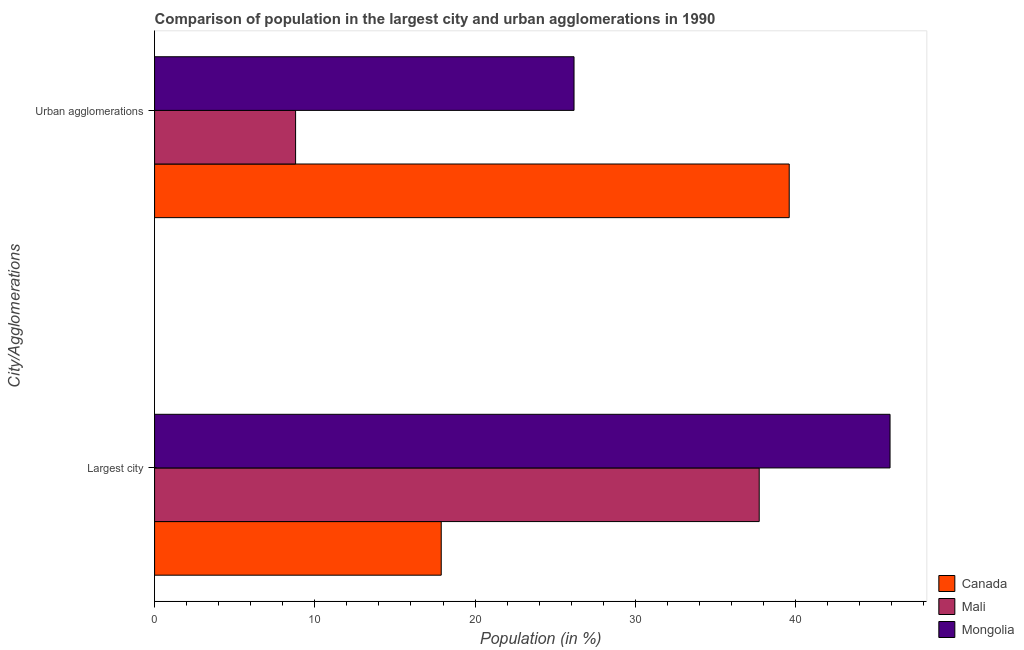How many groups of bars are there?
Keep it short and to the point. 2. Are the number of bars per tick equal to the number of legend labels?
Give a very brief answer. Yes. Are the number of bars on each tick of the Y-axis equal?
Provide a short and direct response. Yes. What is the label of the 1st group of bars from the top?
Your answer should be very brief. Urban agglomerations. What is the population in the largest city in Mongolia?
Give a very brief answer. 45.89. Across all countries, what is the maximum population in urban agglomerations?
Provide a short and direct response. 39.6. Across all countries, what is the minimum population in urban agglomerations?
Ensure brevity in your answer.  8.8. In which country was the population in the largest city maximum?
Offer a terse response. Mongolia. In which country was the population in the largest city minimum?
Ensure brevity in your answer.  Canada. What is the total population in urban agglomerations in the graph?
Provide a succinct answer. 74.58. What is the difference between the population in the largest city in Canada and that in Mongolia?
Provide a succinct answer. -28.01. What is the difference between the population in urban agglomerations in Mali and the population in the largest city in Mongolia?
Provide a short and direct response. -37.09. What is the average population in the largest city per country?
Provide a succinct answer. 33.84. What is the difference between the population in urban agglomerations and population in the largest city in Mongolia?
Provide a succinct answer. -19.72. In how many countries, is the population in urban agglomerations greater than 38 %?
Give a very brief answer. 1. What is the ratio of the population in urban agglomerations in Canada to that in Mongolia?
Provide a short and direct response. 1.51. What does the 2nd bar from the top in Largest city represents?
Your answer should be compact. Mali. What does the 3rd bar from the bottom in Largest city represents?
Your answer should be very brief. Mongolia. How many bars are there?
Give a very brief answer. 6. Are all the bars in the graph horizontal?
Give a very brief answer. Yes. Are the values on the major ticks of X-axis written in scientific E-notation?
Offer a terse response. No. Does the graph contain grids?
Give a very brief answer. No. What is the title of the graph?
Give a very brief answer. Comparison of population in the largest city and urban agglomerations in 1990. Does "Syrian Arab Republic" appear as one of the legend labels in the graph?
Provide a succinct answer. No. What is the label or title of the Y-axis?
Your answer should be compact. City/Agglomerations. What is the Population (in %) of Canada in Largest city?
Your response must be concise. 17.89. What is the Population (in %) in Mali in Largest city?
Provide a short and direct response. 37.73. What is the Population (in %) in Mongolia in Largest city?
Ensure brevity in your answer.  45.89. What is the Population (in %) in Canada in Urban agglomerations?
Your answer should be compact. 39.6. What is the Population (in %) of Mali in Urban agglomerations?
Keep it short and to the point. 8.8. What is the Population (in %) in Mongolia in Urban agglomerations?
Provide a short and direct response. 26.17. Across all City/Agglomerations, what is the maximum Population (in %) in Canada?
Ensure brevity in your answer.  39.6. Across all City/Agglomerations, what is the maximum Population (in %) of Mali?
Make the answer very short. 37.73. Across all City/Agglomerations, what is the maximum Population (in %) of Mongolia?
Keep it short and to the point. 45.89. Across all City/Agglomerations, what is the minimum Population (in %) in Canada?
Provide a short and direct response. 17.89. Across all City/Agglomerations, what is the minimum Population (in %) in Mali?
Your response must be concise. 8.8. Across all City/Agglomerations, what is the minimum Population (in %) of Mongolia?
Your answer should be compact. 26.17. What is the total Population (in %) of Canada in the graph?
Provide a succinct answer. 57.49. What is the total Population (in %) of Mali in the graph?
Give a very brief answer. 46.53. What is the total Population (in %) in Mongolia in the graph?
Offer a very short reply. 72.07. What is the difference between the Population (in %) of Canada in Largest city and that in Urban agglomerations?
Ensure brevity in your answer.  -21.72. What is the difference between the Population (in %) of Mali in Largest city and that in Urban agglomerations?
Ensure brevity in your answer.  28.93. What is the difference between the Population (in %) of Mongolia in Largest city and that in Urban agglomerations?
Ensure brevity in your answer.  19.72. What is the difference between the Population (in %) of Canada in Largest city and the Population (in %) of Mali in Urban agglomerations?
Provide a succinct answer. 9.09. What is the difference between the Population (in %) in Canada in Largest city and the Population (in %) in Mongolia in Urban agglomerations?
Make the answer very short. -8.29. What is the difference between the Population (in %) in Mali in Largest city and the Population (in %) in Mongolia in Urban agglomerations?
Your response must be concise. 11.56. What is the average Population (in %) of Canada per City/Agglomerations?
Provide a succinct answer. 28.75. What is the average Population (in %) in Mali per City/Agglomerations?
Your answer should be compact. 23.27. What is the average Population (in %) of Mongolia per City/Agglomerations?
Give a very brief answer. 36.03. What is the difference between the Population (in %) of Canada and Population (in %) of Mali in Largest city?
Your response must be concise. -19.84. What is the difference between the Population (in %) of Canada and Population (in %) of Mongolia in Largest city?
Offer a terse response. -28.01. What is the difference between the Population (in %) of Mali and Population (in %) of Mongolia in Largest city?
Make the answer very short. -8.16. What is the difference between the Population (in %) of Canada and Population (in %) of Mali in Urban agglomerations?
Your answer should be very brief. 30.8. What is the difference between the Population (in %) of Canada and Population (in %) of Mongolia in Urban agglomerations?
Make the answer very short. 13.43. What is the difference between the Population (in %) of Mali and Population (in %) of Mongolia in Urban agglomerations?
Your response must be concise. -17.38. What is the ratio of the Population (in %) in Canada in Largest city to that in Urban agglomerations?
Make the answer very short. 0.45. What is the ratio of the Population (in %) in Mali in Largest city to that in Urban agglomerations?
Provide a succinct answer. 4.29. What is the ratio of the Population (in %) of Mongolia in Largest city to that in Urban agglomerations?
Your answer should be very brief. 1.75. What is the difference between the highest and the second highest Population (in %) of Canada?
Offer a terse response. 21.72. What is the difference between the highest and the second highest Population (in %) of Mali?
Make the answer very short. 28.93. What is the difference between the highest and the second highest Population (in %) of Mongolia?
Give a very brief answer. 19.72. What is the difference between the highest and the lowest Population (in %) of Canada?
Provide a short and direct response. 21.72. What is the difference between the highest and the lowest Population (in %) of Mali?
Ensure brevity in your answer.  28.93. What is the difference between the highest and the lowest Population (in %) in Mongolia?
Offer a very short reply. 19.72. 